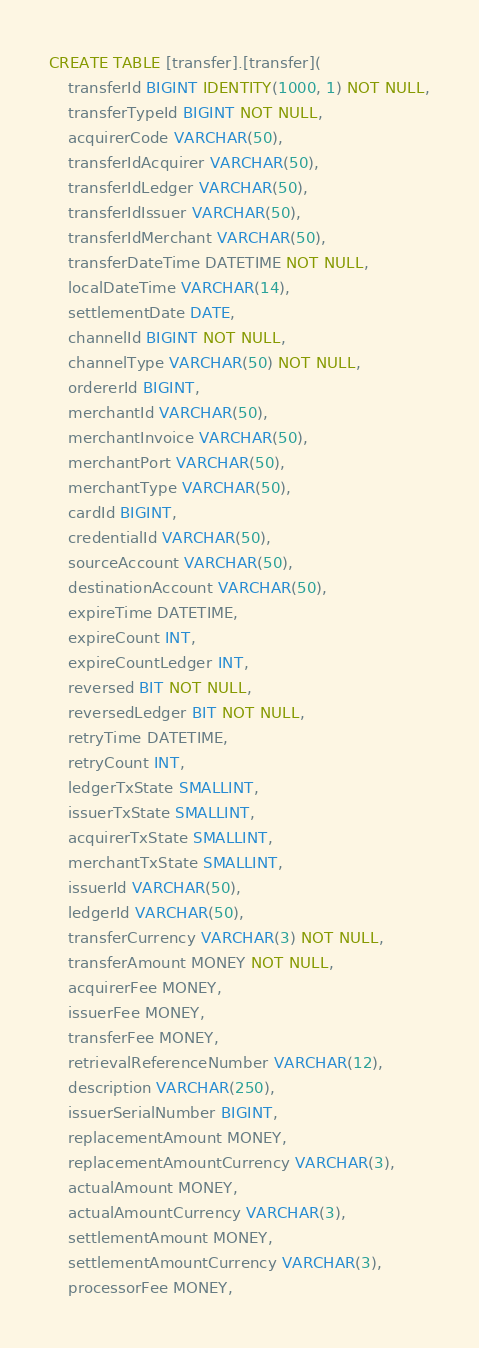Convert code to text. <code><loc_0><loc_0><loc_500><loc_500><_SQL_>CREATE TABLE [transfer].[transfer](
    transferId BIGINT IDENTITY(1000, 1) NOT NULL,
    transferTypeId BIGINT NOT NULL,
    acquirerCode VARCHAR(50),
    transferIdAcquirer VARCHAR(50),
    transferIdLedger VARCHAR(50),
    transferIdIssuer VARCHAR(50),
    transferIdMerchant VARCHAR(50),
    transferDateTime DATETIME NOT NULL,
    localDateTime VARCHAR(14),
    settlementDate DATE,
    channelId BIGINT NOT NULL,
    channelType VARCHAR(50) NOT NULL,
    ordererId BIGINT,
    merchantId VARCHAR(50),
    merchantInvoice VARCHAR(50),
    merchantPort VARCHAR(50),
    merchantType VARCHAR(50),
    cardId BIGINT,
    credentialId VARCHAR(50),
    sourceAccount VARCHAR(50),
    destinationAccount VARCHAR(50),
    expireTime DATETIME,
    expireCount INT,
    expireCountLedger INT,
    reversed BIT NOT NULL,
    reversedLedger BIT NOT NULL,
    retryTime DATETIME,
    retryCount INT,
    ledgerTxState SMALLINT,
    issuerTxState SMALLINT,
    acquirerTxState SMALLINT,
    merchantTxState SMALLINT,
    issuerId VARCHAR(50),
    ledgerId VARCHAR(50),
    transferCurrency VARCHAR(3) NOT NULL,
    transferAmount MONEY NOT NULL,
    acquirerFee MONEY,
    issuerFee MONEY,
    transferFee MONEY,
    retrievalReferenceNumber VARCHAR(12),
    description VARCHAR(250),
    issuerSerialNumber BIGINT,
    replacementAmount MONEY,
    replacementAmountCurrency VARCHAR(3),
    actualAmount MONEY,
    actualAmountCurrency VARCHAR(3),
    settlementAmount MONEY,
    settlementAmountCurrency VARCHAR(3),
    processorFee MONEY,</code> 